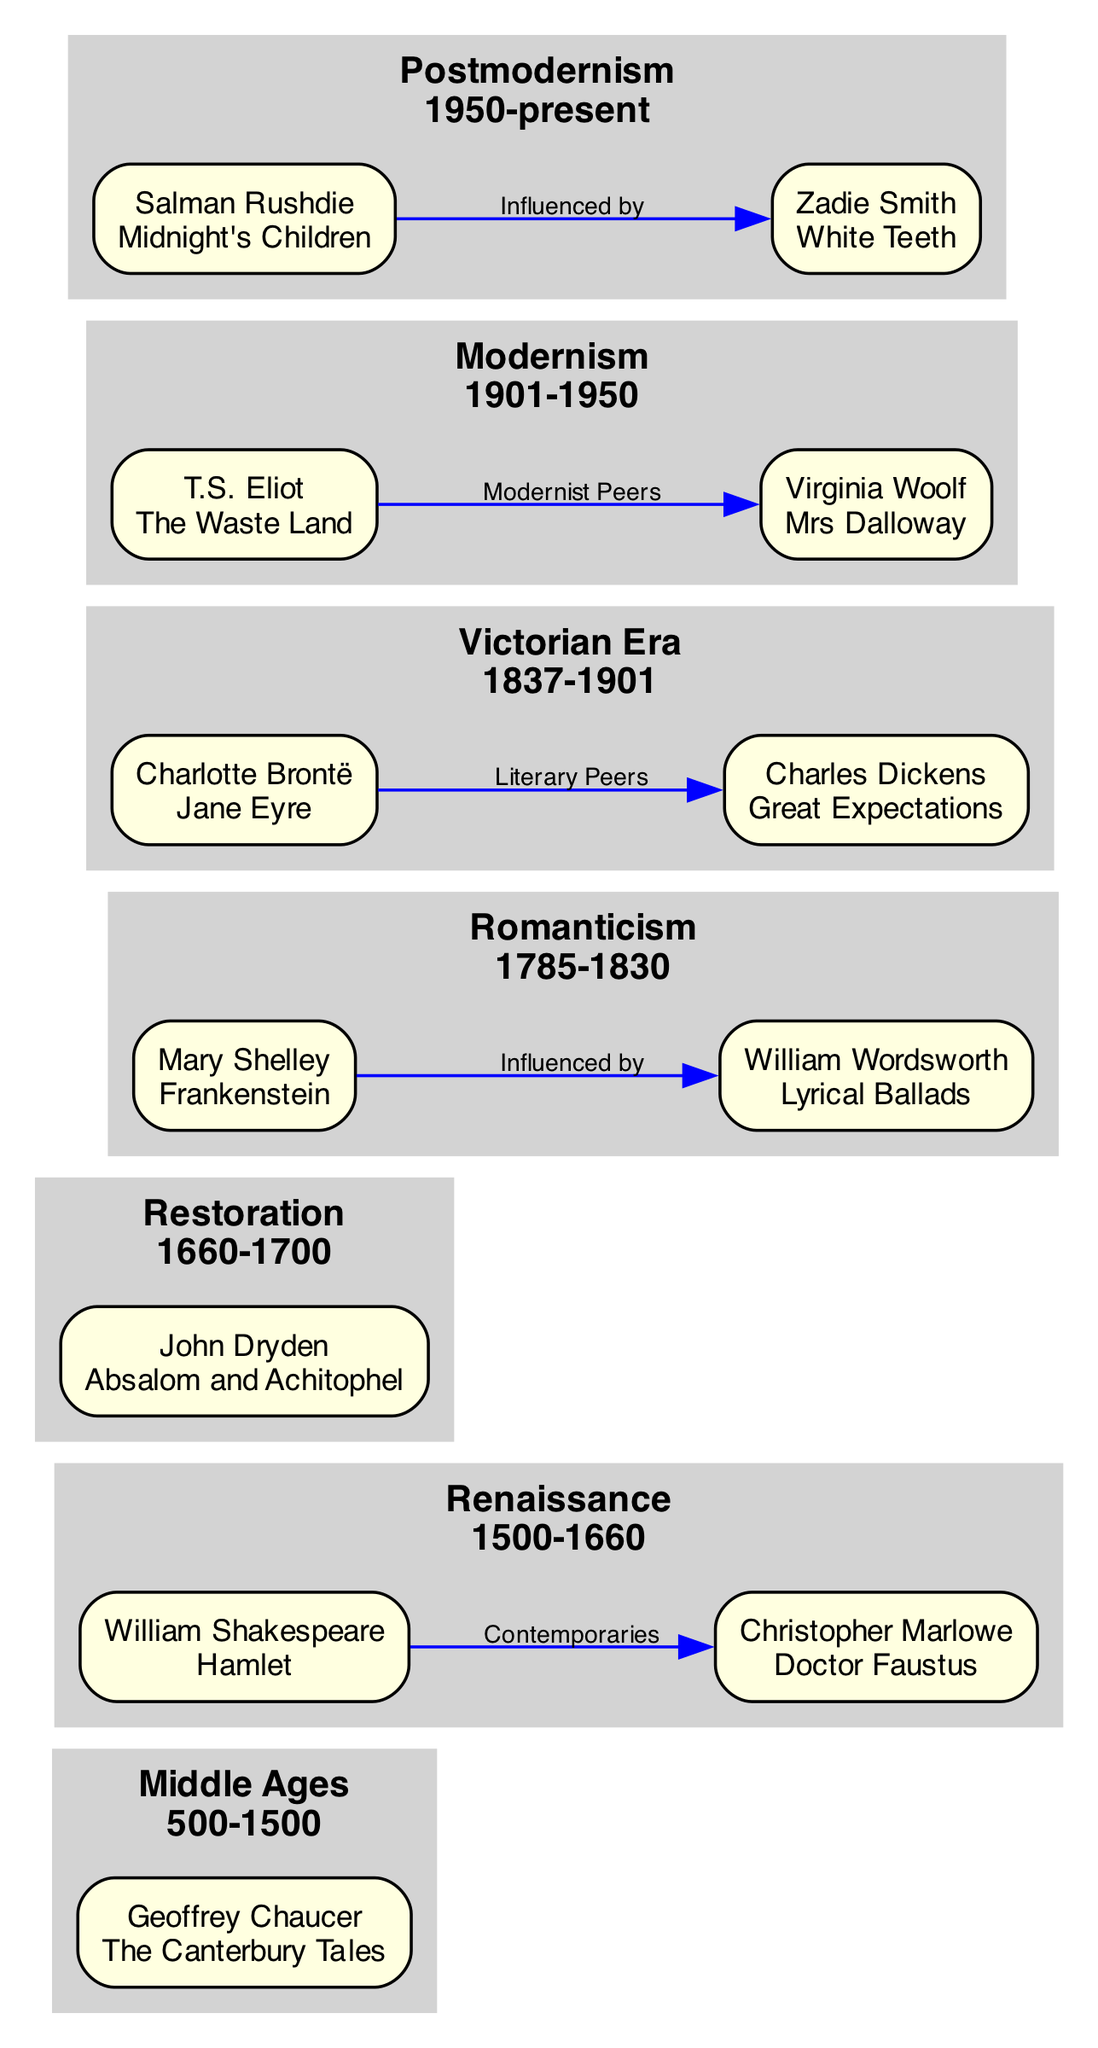What author is associated with "The Canterbury Tales"? The diagram clearly indicates that Geoffrey Chaucer is the author of "The Canterbury Tales" as he is listed under the Middle Ages epoch with this specific work noted.
Answer: Geoffrey Chaucer Which epoch features "Frankenstein"? By looking at the diagram, "Frankenstein" is attributed to Mary Shelley, who is listed under the Romanticism epoch, which spans from 1785 to 1830.
Answer: Romanticism How many key authors are listed under the Victorian Era? The diagram displays two authors under the Victorian Era: Charles Dickens and Charlotte Brontë, so by counting them, the total is two.
Answer: 2 What is the relationship between William Shakespeare and Christopher Marlowe? The diagram illustrates that they are labeled as "Contemporaries", which indicates that their lives and works occurred during the same period, specifically in the Renaissance epoch.
Answer: Contemporaries Which author influenced Mary Shelley? According to the diagram, the influence is defined as coming from William Wordsworth, and this is explicitly stated in a connection labeled "Influenced by".
Answer: William Wordsworth Who wrote "Great Expectations"? The diagram provides the name Charles Dickens associated with "Great Expectations", as listed under the Victorian Era.
Answer: Charles Dickens What is the span of dates for the Modernism epoch? The diagram specifies that Modernism spans from 1901 to 1950, as indicated in the section labeled for this epoch.
Answer: 1901-1950 Which author is connected to Zadie Smith? The diagram shows that Salman Rushdie is the author connected to Zadie Smith, categorized under the relationship "Influenced by".
Answer: Salman Rushdie How many epochs are represented in the diagram? By reviewing the epochs section, we find there are seven distinct epochs outlined in the diagram from Middle Ages to Postmodernism.
Answer: 7 